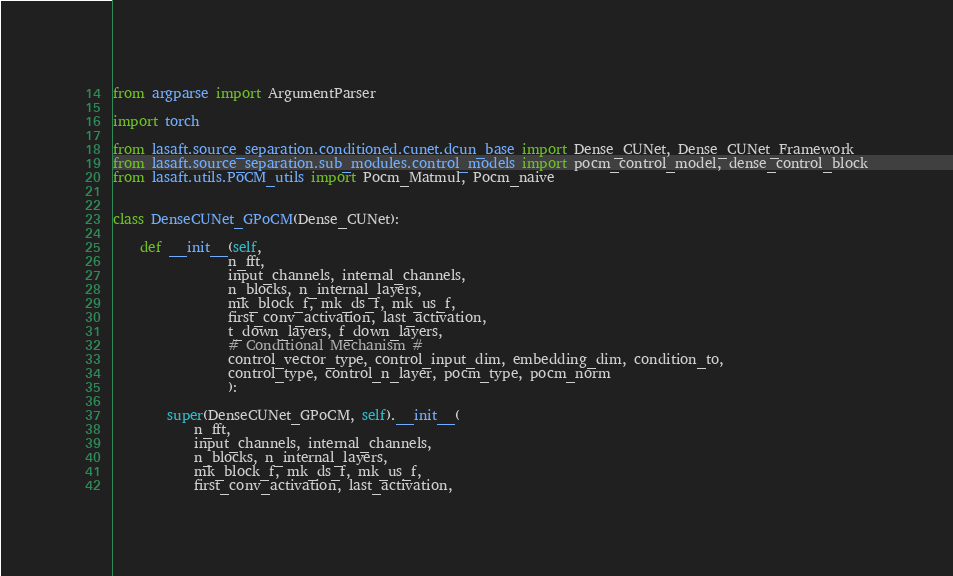Convert code to text. <code><loc_0><loc_0><loc_500><loc_500><_Python_>from argparse import ArgumentParser

import torch

from lasaft.source_separation.conditioned.cunet.dcun_base import Dense_CUNet, Dense_CUNet_Framework
from lasaft.source_separation.sub_modules.control_models import pocm_control_model, dense_control_block
from lasaft.utils.PoCM_utils import Pocm_Matmul, Pocm_naive


class DenseCUNet_GPoCM(Dense_CUNet):

    def __init__(self,
                 n_fft,
                 input_channels, internal_channels,
                 n_blocks, n_internal_layers,
                 mk_block_f, mk_ds_f, mk_us_f,
                 first_conv_activation, last_activation,
                 t_down_layers, f_down_layers,
                 # Conditional Mechanism #
                 control_vector_type, control_input_dim, embedding_dim, condition_to,
                 control_type, control_n_layer, pocm_type, pocm_norm
                 ):

        super(DenseCUNet_GPoCM, self).__init__(
            n_fft,
            input_channels, internal_channels,
            n_blocks, n_internal_layers,
            mk_block_f, mk_ds_f, mk_us_f,
            first_conv_activation, last_activation,</code> 